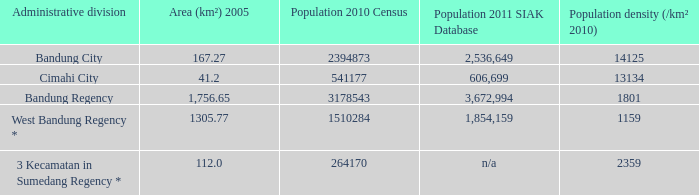Help me parse the entirety of this table. {'header': ['Administrative division', 'Area (km²) 2005', 'Population 2010 Census', 'Population 2011 SIAK Database', 'Population density (/km² 2010)'], 'rows': [['Bandung City', '167.27', '2394873', '2,536,649', '14125'], ['Cimahi City', '41.2', '541177', '606,699', '13134'], ['Bandung Regency', '1,756.65', '3178543', '3,672,994', '1801'], ['West Bandung Regency *', '1305.77', '1510284', '1,854,159', '1159'], ['3 Kecamatan in Sumedang Regency *', '112.0', '264170', 'n/a', '2359']]} Which administrative division had a population of 2011 according to the siak database of 3,672,994? Bandung Regency. 